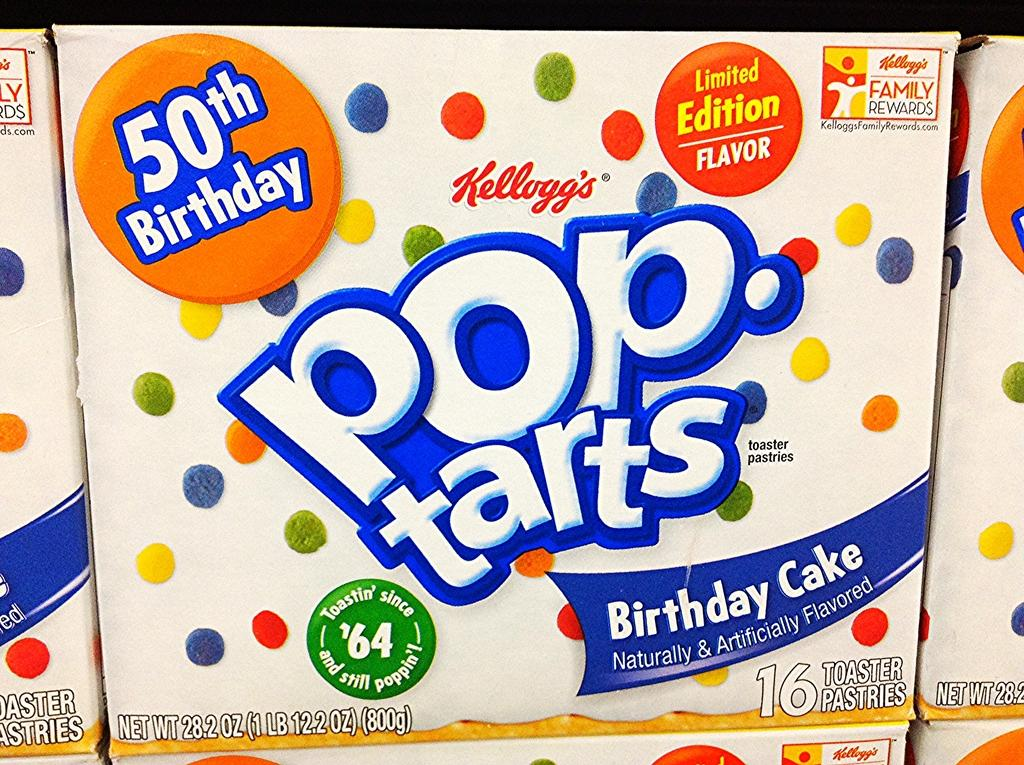What objects are visible in the image? There are boxes in the image. How are the boxes arranged in the image? The boxes are arranged on a shelf. What type of scarf is draped over the boxes on the shelf? There is no scarf present in the image; only boxes can be seen on the shelf. 